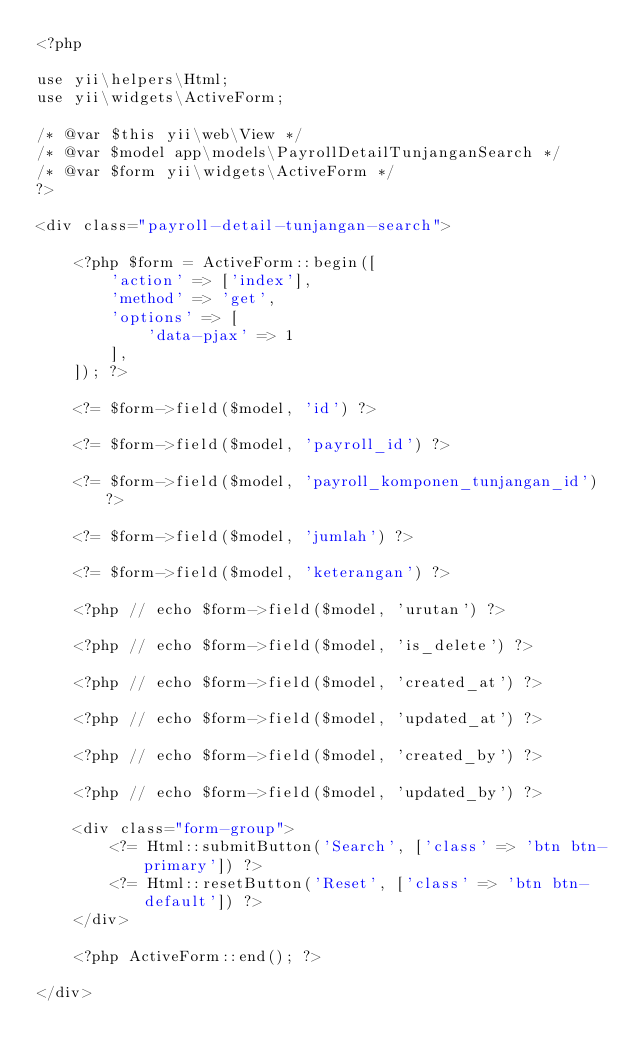<code> <loc_0><loc_0><loc_500><loc_500><_PHP_><?php

use yii\helpers\Html;
use yii\widgets\ActiveForm;

/* @var $this yii\web\View */
/* @var $model app\models\PayrollDetailTunjanganSearch */
/* @var $form yii\widgets\ActiveForm */
?>

<div class="payroll-detail-tunjangan-search">

    <?php $form = ActiveForm::begin([
        'action' => ['index'],
        'method' => 'get',
        'options' => [
            'data-pjax' => 1
        ],
    ]); ?>

    <?= $form->field($model, 'id') ?>

    <?= $form->field($model, 'payroll_id') ?>

    <?= $form->field($model, 'payroll_komponen_tunjangan_id') ?>

    <?= $form->field($model, 'jumlah') ?>

    <?= $form->field($model, 'keterangan') ?>

    <?php // echo $form->field($model, 'urutan') ?>

    <?php // echo $form->field($model, 'is_delete') ?>

    <?php // echo $form->field($model, 'created_at') ?>

    <?php // echo $form->field($model, 'updated_at') ?>

    <?php // echo $form->field($model, 'created_by') ?>

    <?php // echo $form->field($model, 'updated_by') ?>

    <div class="form-group">
        <?= Html::submitButton('Search', ['class' => 'btn btn-primary']) ?>
        <?= Html::resetButton('Reset', ['class' => 'btn btn-default']) ?>
    </div>

    <?php ActiveForm::end(); ?>

</div>
</code> 